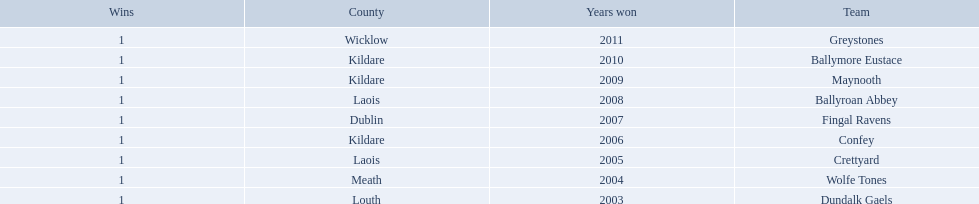Where is ballymore eustace from? Kildare. What teams other than ballymore eustace is from kildare? Maynooth, Confey. Between maynooth and confey, which won in 2009? Maynooth. What county is the team that won in 2009 from? Kildare. What is the teams name? Maynooth. What county is ballymore eustace from? Kildare. Besides convey, which other team is from the same county? Maynooth. 